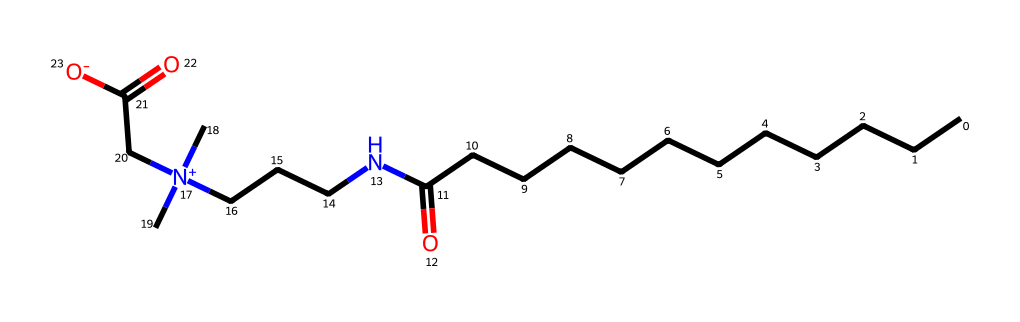What is the molecular formula of cocamidopropyl betaine? By analyzing the SMILES representation, you can count the number of each type of atom present. There are 15 carbons, 30 hydrogens, 1 nitrogen, and 2 oxygens. Therefore, the molecular formula is C15H30N2O2.
Answer: C15H30N2O2 How many nitrogen atoms are in cocamidopropyl betaine? The SMILES representation includes two nitrogen atoms, as indicated by the 'N' letters in the structure.
Answer: 2 What type of functional groups are present in this molecule? In the SMILES, the 'N' represents amine or ammonium groups, and the '=O' represents carbonyl (ketone) groups. Based on this, we identify amine and carboxylic acid functional groups.
Answer: amine and carboxylic acid What structural feature of cocamidopropyl betaine contributes to its surfactant properties? The presence of both hydrophilic (water-loving) and hydrophobic (water-repelling) regions indicates amphiphilicity. The positively charged quaternary nitrogen and the long hydrocarbon tail demonstrate these properties.
Answer: amphiphilicity Does cocamidopropyl betaine have a hydrophobic tail? The long hydrocarbon chain (CCCCCCCCCCCC) in the structure indicates that it indeed has a hydrophobic tail, which is essential for its surfactant function.
Answer: yes What charge does the nitrogen atom in cocamidopropyl betaine carry? The nitrogen in the quaternary ammonium structure has a positive charge, indicated by the '[N+]' notation in the SMILES representation.
Answer: positive charge What is the main purpose of cocamidopropyl betaine in body wash? Cocamidopropyl betaine primarily functions as a surfactant, which helps create lather and cleanse the skin by lowering surface tension.
Answer: surfactant 